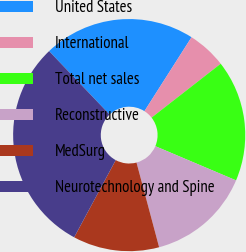<chart> <loc_0><loc_0><loc_500><loc_500><pie_chart><fcel>United States<fcel>International<fcel>Total net sales<fcel>Reconstructive<fcel>MedSurg<fcel>Neurotechnology and Spine<nl><fcel>21.15%<fcel>5.43%<fcel>16.92%<fcel>14.47%<fcel>12.01%<fcel>30.02%<nl></chart> 